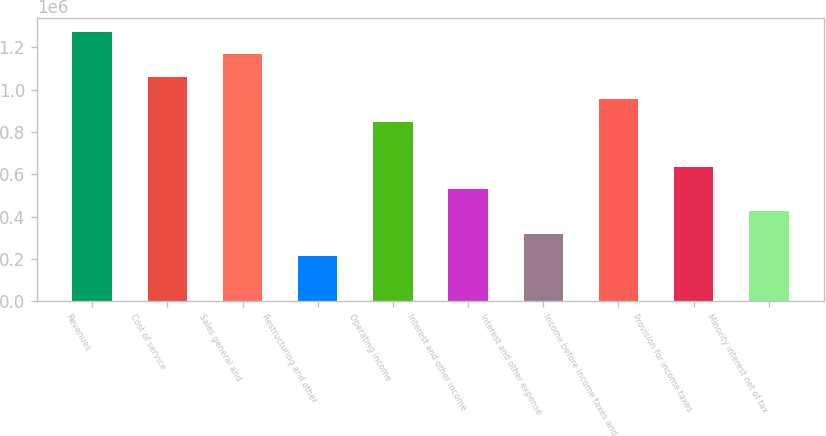Convert chart to OTSL. <chart><loc_0><loc_0><loc_500><loc_500><bar_chart><fcel>Revenues<fcel>Cost of service<fcel>Sales general and<fcel>Restructuring and other<fcel>Operating income<fcel>Interest and other income<fcel>Interest and other expense<fcel>Income before income taxes and<fcel>Provision for income taxes<fcel>Minority interest net of tax<nl><fcel>1.27383e+06<fcel>1.06152e+06<fcel>1.16768e+06<fcel>212306<fcel>849219<fcel>530762<fcel>318458<fcel>955371<fcel>636915<fcel>424610<nl></chart> 